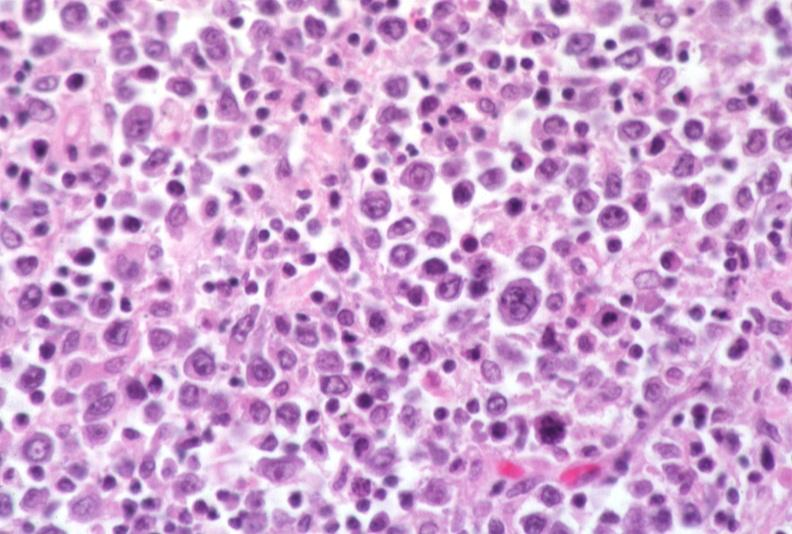does this image show lymph node, lymphoma?
Answer the question using a single word or phrase. Yes 